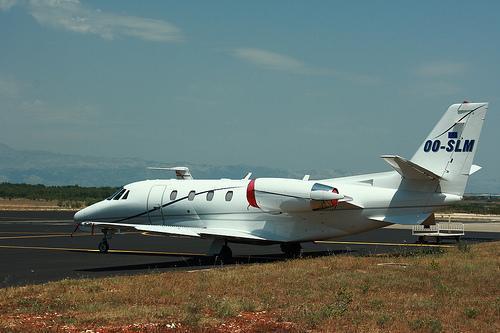How many airplanes are there?
Give a very brief answer. 1. 